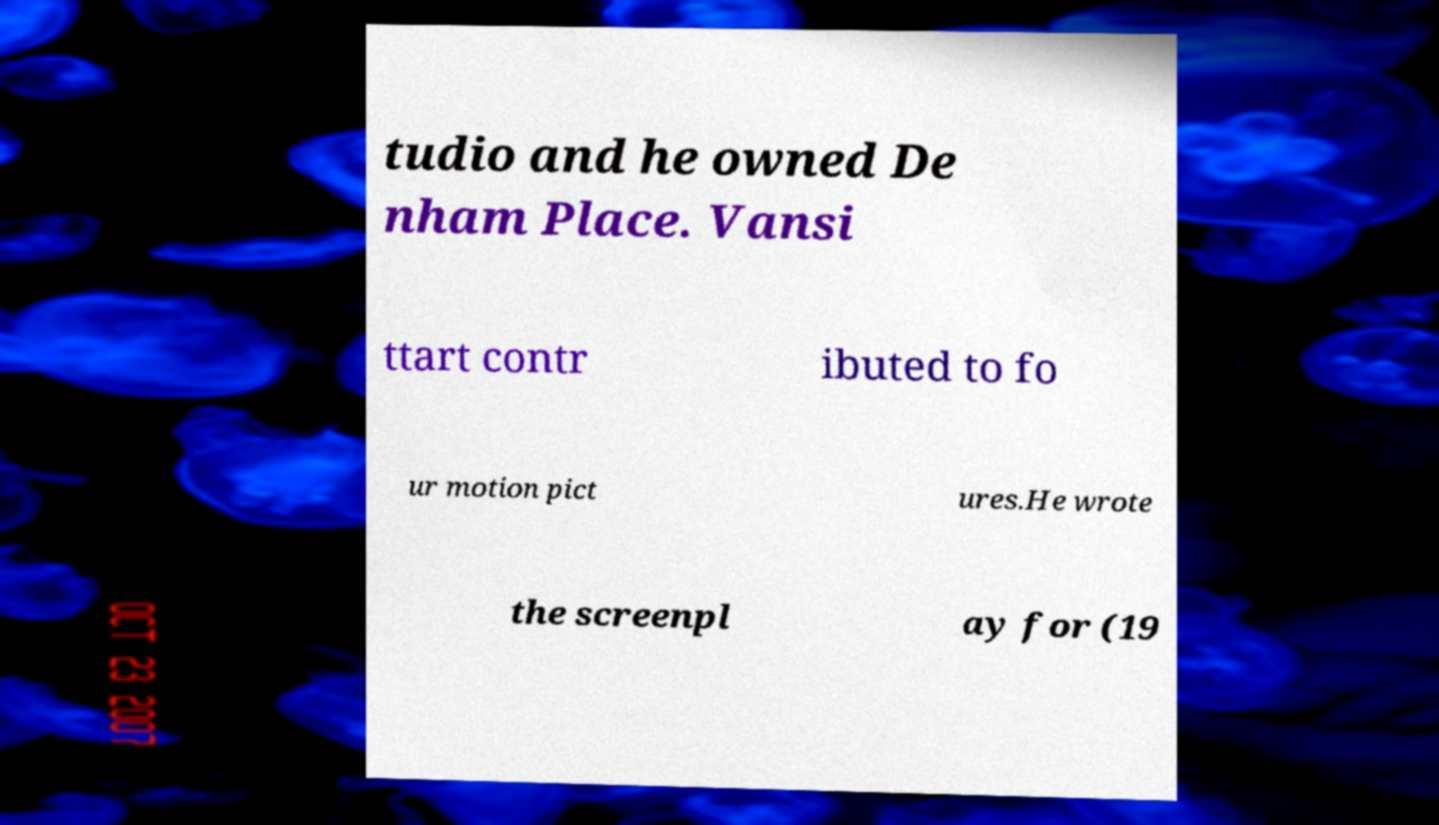Please read and relay the text visible in this image. What does it say? tudio and he owned De nham Place. Vansi ttart contr ibuted to fo ur motion pict ures.He wrote the screenpl ay for (19 